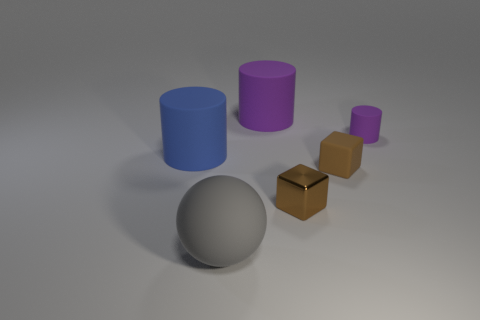Subtract all big cylinders. How many cylinders are left? 1 Add 1 small purple cylinders. How many objects exist? 7 Subtract all blocks. How many objects are left? 4 Subtract all balls. Subtract all tiny brown blocks. How many objects are left? 3 Add 5 matte blocks. How many matte blocks are left? 6 Add 1 big spheres. How many big spheres exist? 2 Subtract 0 red cylinders. How many objects are left? 6 